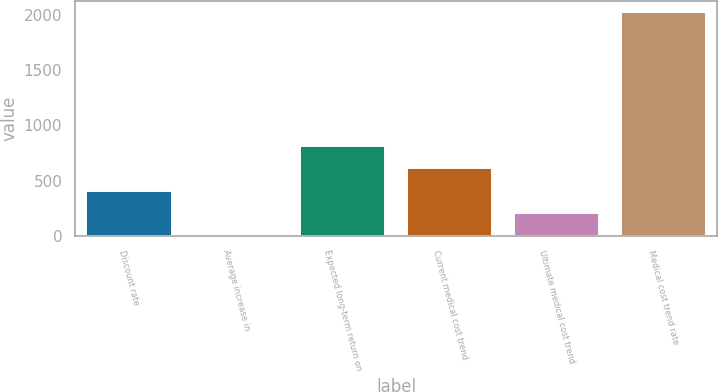Convert chart to OTSL. <chart><loc_0><loc_0><loc_500><loc_500><bar_chart><fcel>Discount rate<fcel>Average increase in<fcel>Expected long-term return on<fcel>Current medical cost trend<fcel>Ultimate medical cost trend<fcel>Medical cost trend rate<nl><fcel>408<fcel>3<fcel>813<fcel>610.5<fcel>205.5<fcel>2028<nl></chart> 